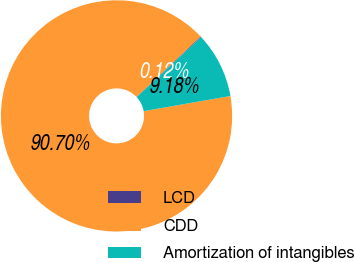<chart> <loc_0><loc_0><loc_500><loc_500><pie_chart><fcel>LCD<fcel>CDD<fcel>Amortization of intangibles<nl><fcel>0.12%<fcel>90.7%<fcel>9.18%<nl></chart> 